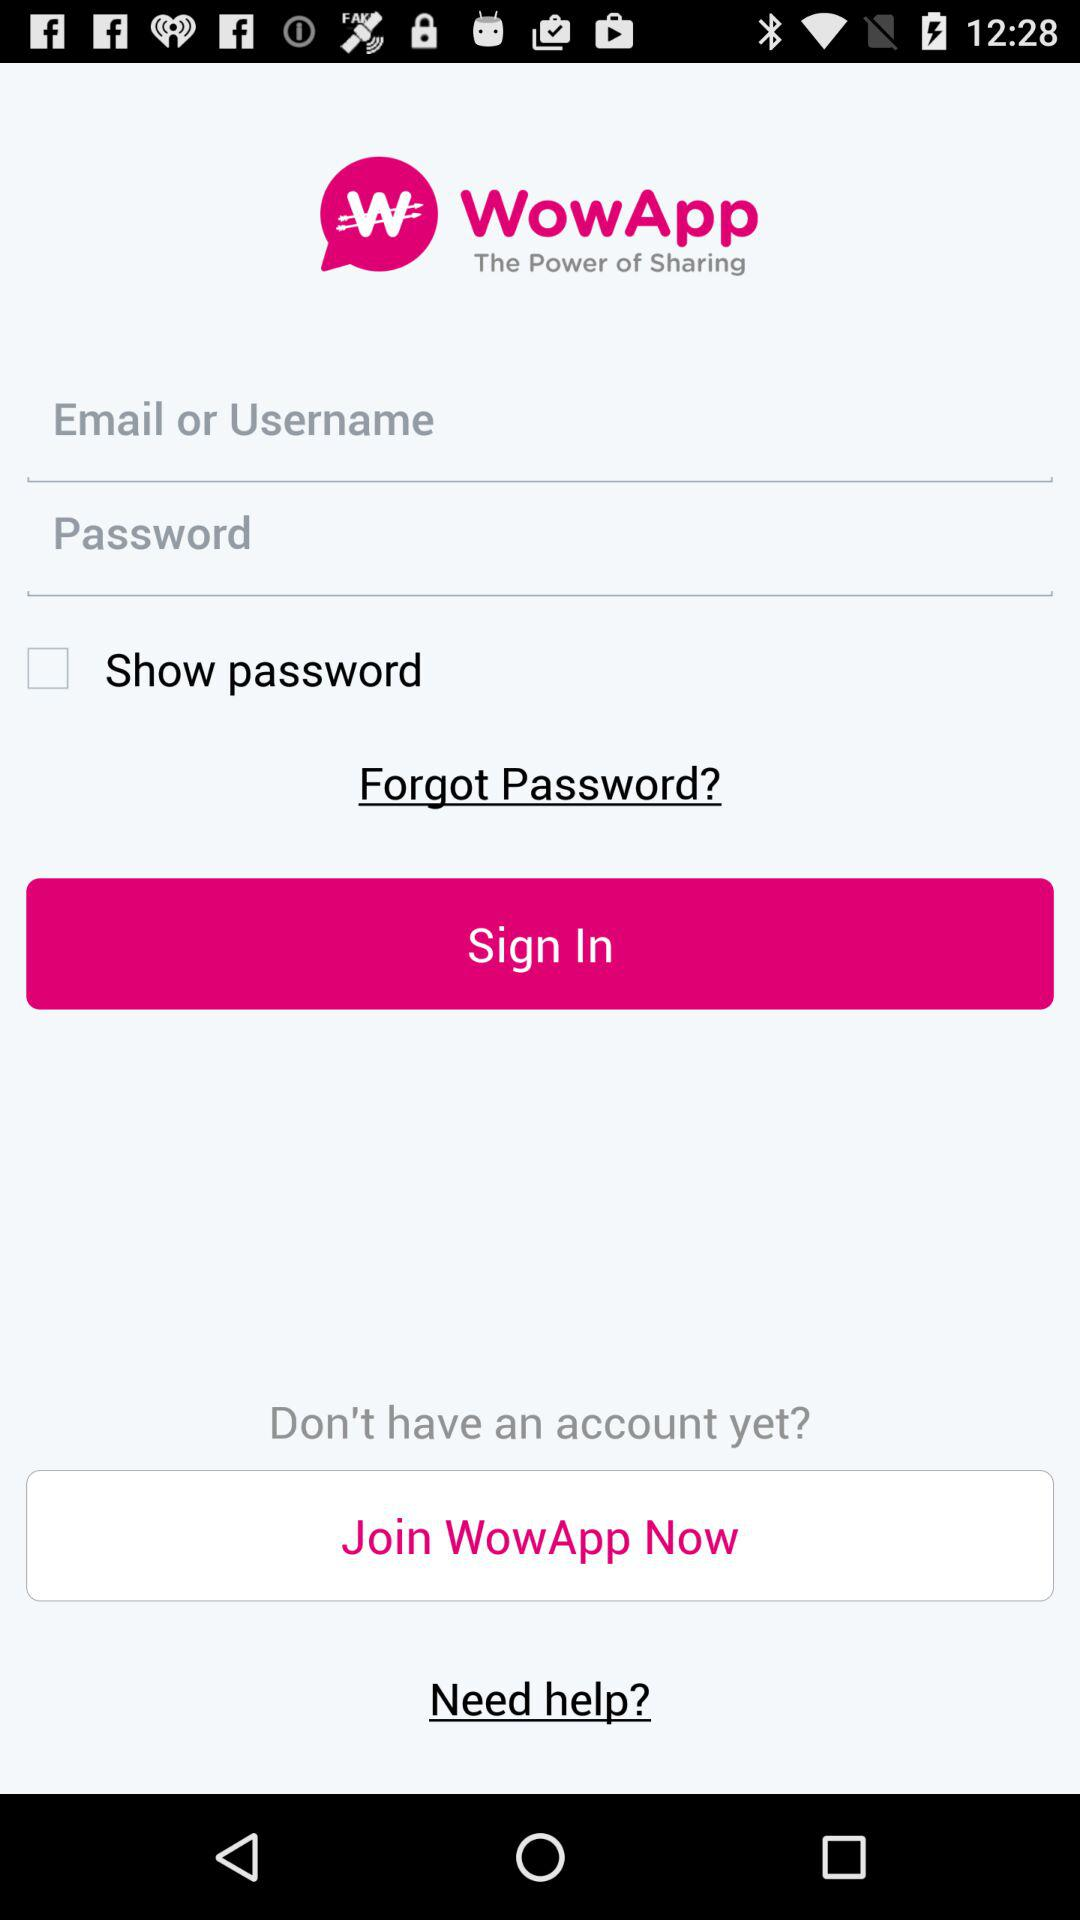How many text inputs are there for logging in?
Answer the question using a single word or phrase. 2 